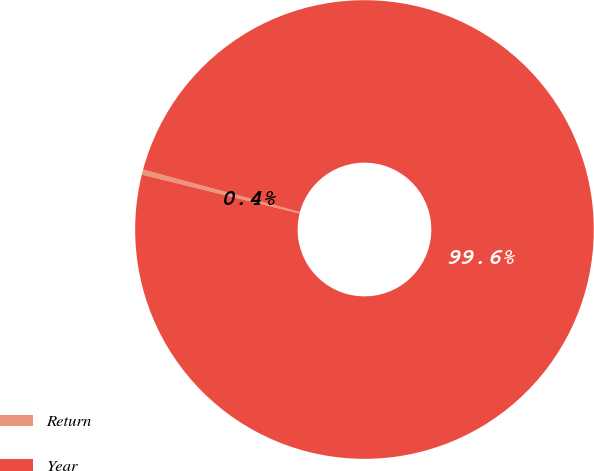Convert chart. <chart><loc_0><loc_0><loc_500><loc_500><pie_chart><fcel>Return<fcel>Year<nl><fcel>0.36%<fcel>99.64%<nl></chart> 